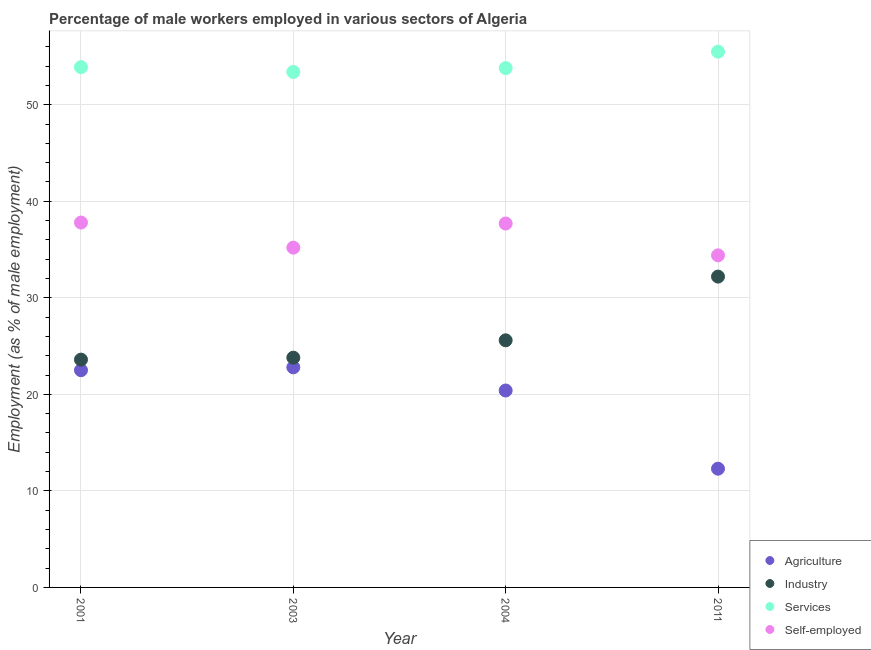How many different coloured dotlines are there?
Your answer should be very brief. 4. What is the percentage of male workers in industry in 2003?
Ensure brevity in your answer.  23.8. Across all years, what is the maximum percentage of male workers in services?
Make the answer very short. 55.5. Across all years, what is the minimum percentage of male workers in industry?
Your answer should be very brief. 23.6. In which year was the percentage of self employed male workers minimum?
Offer a very short reply. 2011. What is the total percentage of self employed male workers in the graph?
Give a very brief answer. 145.1. What is the difference between the percentage of male workers in services in 2004 and that in 2011?
Your answer should be very brief. -1.7. What is the difference between the percentage of male workers in services in 2011 and the percentage of male workers in agriculture in 2003?
Provide a succinct answer. 32.7. What is the average percentage of male workers in agriculture per year?
Keep it short and to the point. 19.5. In the year 2001, what is the difference between the percentage of male workers in services and percentage of male workers in agriculture?
Offer a terse response. 31.4. In how many years, is the percentage of male workers in services greater than 24 %?
Offer a terse response. 4. What is the ratio of the percentage of male workers in services in 2003 to that in 2004?
Your response must be concise. 0.99. Is the percentage of male workers in industry in 2003 less than that in 2004?
Your answer should be very brief. Yes. What is the difference between the highest and the second highest percentage of male workers in industry?
Provide a short and direct response. 6.6. What is the difference between the highest and the lowest percentage of male workers in services?
Your answer should be very brief. 2.1. Is it the case that in every year, the sum of the percentage of male workers in services and percentage of male workers in industry is greater than the sum of percentage of male workers in agriculture and percentage of self employed male workers?
Provide a succinct answer. Yes. Is it the case that in every year, the sum of the percentage of male workers in agriculture and percentage of male workers in industry is greater than the percentage of male workers in services?
Your answer should be very brief. No. Is the percentage of male workers in agriculture strictly greater than the percentage of male workers in services over the years?
Keep it short and to the point. No. Is the percentage of self employed male workers strictly less than the percentage of male workers in agriculture over the years?
Your response must be concise. No. Are the values on the major ticks of Y-axis written in scientific E-notation?
Keep it short and to the point. No. Does the graph contain any zero values?
Offer a very short reply. No. Does the graph contain grids?
Your answer should be compact. Yes. Where does the legend appear in the graph?
Provide a short and direct response. Bottom right. What is the title of the graph?
Offer a terse response. Percentage of male workers employed in various sectors of Algeria. What is the label or title of the Y-axis?
Your answer should be compact. Employment (as % of male employment). What is the Employment (as % of male employment) of Industry in 2001?
Your answer should be very brief. 23.6. What is the Employment (as % of male employment) in Services in 2001?
Provide a short and direct response. 53.9. What is the Employment (as % of male employment) of Self-employed in 2001?
Your answer should be compact. 37.8. What is the Employment (as % of male employment) of Agriculture in 2003?
Your response must be concise. 22.8. What is the Employment (as % of male employment) of Industry in 2003?
Make the answer very short. 23.8. What is the Employment (as % of male employment) of Services in 2003?
Your answer should be very brief. 53.4. What is the Employment (as % of male employment) of Self-employed in 2003?
Your answer should be very brief. 35.2. What is the Employment (as % of male employment) of Agriculture in 2004?
Provide a short and direct response. 20.4. What is the Employment (as % of male employment) of Industry in 2004?
Your response must be concise. 25.6. What is the Employment (as % of male employment) of Services in 2004?
Your answer should be compact. 53.8. What is the Employment (as % of male employment) in Self-employed in 2004?
Your answer should be compact. 37.7. What is the Employment (as % of male employment) in Agriculture in 2011?
Make the answer very short. 12.3. What is the Employment (as % of male employment) of Industry in 2011?
Keep it short and to the point. 32.2. What is the Employment (as % of male employment) in Services in 2011?
Provide a short and direct response. 55.5. What is the Employment (as % of male employment) in Self-employed in 2011?
Provide a succinct answer. 34.4. Across all years, what is the maximum Employment (as % of male employment) in Agriculture?
Your response must be concise. 22.8. Across all years, what is the maximum Employment (as % of male employment) of Industry?
Make the answer very short. 32.2. Across all years, what is the maximum Employment (as % of male employment) in Services?
Your answer should be compact. 55.5. Across all years, what is the maximum Employment (as % of male employment) in Self-employed?
Keep it short and to the point. 37.8. Across all years, what is the minimum Employment (as % of male employment) of Agriculture?
Give a very brief answer. 12.3. Across all years, what is the minimum Employment (as % of male employment) of Industry?
Make the answer very short. 23.6. Across all years, what is the minimum Employment (as % of male employment) in Services?
Provide a short and direct response. 53.4. Across all years, what is the minimum Employment (as % of male employment) of Self-employed?
Your answer should be very brief. 34.4. What is the total Employment (as % of male employment) of Agriculture in the graph?
Your answer should be compact. 78. What is the total Employment (as % of male employment) of Industry in the graph?
Offer a very short reply. 105.2. What is the total Employment (as % of male employment) in Services in the graph?
Give a very brief answer. 216.6. What is the total Employment (as % of male employment) of Self-employed in the graph?
Provide a short and direct response. 145.1. What is the difference between the Employment (as % of male employment) in Services in 2001 and that in 2003?
Give a very brief answer. 0.5. What is the difference between the Employment (as % of male employment) in Self-employed in 2001 and that in 2003?
Your answer should be compact. 2.6. What is the difference between the Employment (as % of male employment) in Agriculture in 2001 and that in 2004?
Give a very brief answer. 2.1. What is the difference between the Employment (as % of male employment) in Industry in 2001 and that in 2004?
Ensure brevity in your answer.  -2. What is the difference between the Employment (as % of male employment) of Services in 2001 and that in 2004?
Offer a very short reply. 0.1. What is the difference between the Employment (as % of male employment) of Self-employed in 2001 and that in 2004?
Provide a short and direct response. 0.1. What is the difference between the Employment (as % of male employment) in Industry in 2001 and that in 2011?
Keep it short and to the point. -8.6. What is the difference between the Employment (as % of male employment) in Services in 2001 and that in 2011?
Keep it short and to the point. -1.6. What is the difference between the Employment (as % of male employment) in Agriculture in 2003 and that in 2004?
Make the answer very short. 2.4. What is the difference between the Employment (as % of male employment) of Industry in 2003 and that in 2004?
Ensure brevity in your answer.  -1.8. What is the difference between the Employment (as % of male employment) of Services in 2003 and that in 2011?
Your answer should be compact. -2.1. What is the difference between the Employment (as % of male employment) of Self-employed in 2003 and that in 2011?
Make the answer very short. 0.8. What is the difference between the Employment (as % of male employment) of Industry in 2004 and that in 2011?
Your answer should be compact. -6.6. What is the difference between the Employment (as % of male employment) of Services in 2004 and that in 2011?
Ensure brevity in your answer.  -1.7. What is the difference between the Employment (as % of male employment) in Self-employed in 2004 and that in 2011?
Your response must be concise. 3.3. What is the difference between the Employment (as % of male employment) in Agriculture in 2001 and the Employment (as % of male employment) in Services in 2003?
Ensure brevity in your answer.  -30.9. What is the difference between the Employment (as % of male employment) of Industry in 2001 and the Employment (as % of male employment) of Services in 2003?
Your response must be concise. -29.8. What is the difference between the Employment (as % of male employment) of Industry in 2001 and the Employment (as % of male employment) of Self-employed in 2003?
Keep it short and to the point. -11.6. What is the difference between the Employment (as % of male employment) of Services in 2001 and the Employment (as % of male employment) of Self-employed in 2003?
Keep it short and to the point. 18.7. What is the difference between the Employment (as % of male employment) in Agriculture in 2001 and the Employment (as % of male employment) in Services in 2004?
Provide a succinct answer. -31.3. What is the difference between the Employment (as % of male employment) in Agriculture in 2001 and the Employment (as % of male employment) in Self-employed in 2004?
Your answer should be very brief. -15.2. What is the difference between the Employment (as % of male employment) in Industry in 2001 and the Employment (as % of male employment) in Services in 2004?
Your response must be concise. -30.2. What is the difference between the Employment (as % of male employment) in Industry in 2001 and the Employment (as % of male employment) in Self-employed in 2004?
Provide a short and direct response. -14.1. What is the difference between the Employment (as % of male employment) of Services in 2001 and the Employment (as % of male employment) of Self-employed in 2004?
Provide a short and direct response. 16.2. What is the difference between the Employment (as % of male employment) of Agriculture in 2001 and the Employment (as % of male employment) of Services in 2011?
Offer a terse response. -33. What is the difference between the Employment (as % of male employment) in Agriculture in 2001 and the Employment (as % of male employment) in Self-employed in 2011?
Keep it short and to the point. -11.9. What is the difference between the Employment (as % of male employment) in Industry in 2001 and the Employment (as % of male employment) in Services in 2011?
Make the answer very short. -31.9. What is the difference between the Employment (as % of male employment) of Agriculture in 2003 and the Employment (as % of male employment) of Industry in 2004?
Make the answer very short. -2.8. What is the difference between the Employment (as % of male employment) in Agriculture in 2003 and the Employment (as % of male employment) in Services in 2004?
Offer a terse response. -31. What is the difference between the Employment (as % of male employment) of Agriculture in 2003 and the Employment (as % of male employment) of Self-employed in 2004?
Your answer should be very brief. -14.9. What is the difference between the Employment (as % of male employment) of Industry in 2003 and the Employment (as % of male employment) of Self-employed in 2004?
Offer a very short reply. -13.9. What is the difference between the Employment (as % of male employment) of Agriculture in 2003 and the Employment (as % of male employment) of Services in 2011?
Your response must be concise. -32.7. What is the difference between the Employment (as % of male employment) in Industry in 2003 and the Employment (as % of male employment) in Services in 2011?
Offer a terse response. -31.7. What is the difference between the Employment (as % of male employment) in Industry in 2003 and the Employment (as % of male employment) in Self-employed in 2011?
Ensure brevity in your answer.  -10.6. What is the difference between the Employment (as % of male employment) in Services in 2003 and the Employment (as % of male employment) in Self-employed in 2011?
Provide a short and direct response. 19. What is the difference between the Employment (as % of male employment) in Agriculture in 2004 and the Employment (as % of male employment) in Services in 2011?
Make the answer very short. -35.1. What is the difference between the Employment (as % of male employment) of Agriculture in 2004 and the Employment (as % of male employment) of Self-employed in 2011?
Your answer should be compact. -14. What is the difference between the Employment (as % of male employment) of Industry in 2004 and the Employment (as % of male employment) of Services in 2011?
Keep it short and to the point. -29.9. What is the average Employment (as % of male employment) of Agriculture per year?
Provide a succinct answer. 19.5. What is the average Employment (as % of male employment) of Industry per year?
Offer a terse response. 26.3. What is the average Employment (as % of male employment) in Services per year?
Provide a succinct answer. 54.15. What is the average Employment (as % of male employment) in Self-employed per year?
Your response must be concise. 36.27. In the year 2001, what is the difference between the Employment (as % of male employment) of Agriculture and Employment (as % of male employment) of Industry?
Ensure brevity in your answer.  -1.1. In the year 2001, what is the difference between the Employment (as % of male employment) in Agriculture and Employment (as % of male employment) in Services?
Your response must be concise. -31.4. In the year 2001, what is the difference between the Employment (as % of male employment) of Agriculture and Employment (as % of male employment) of Self-employed?
Provide a succinct answer. -15.3. In the year 2001, what is the difference between the Employment (as % of male employment) in Industry and Employment (as % of male employment) in Services?
Keep it short and to the point. -30.3. In the year 2001, what is the difference between the Employment (as % of male employment) of Services and Employment (as % of male employment) of Self-employed?
Offer a very short reply. 16.1. In the year 2003, what is the difference between the Employment (as % of male employment) of Agriculture and Employment (as % of male employment) of Services?
Provide a short and direct response. -30.6. In the year 2003, what is the difference between the Employment (as % of male employment) in Agriculture and Employment (as % of male employment) in Self-employed?
Your answer should be compact. -12.4. In the year 2003, what is the difference between the Employment (as % of male employment) in Industry and Employment (as % of male employment) in Services?
Offer a very short reply. -29.6. In the year 2003, what is the difference between the Employment (as % of male employment) of Industry and Employment (as % of male employment) of Self-employed?
Your answer should be very brief. -11.4. In the year 2004, what is the difference between the Employment (as % of male employment) of Agriculture and Employment (as % of male employment) of Industry?
Provide a succinct answer. -5.2. In the year 2004, what is the difference between the Employment (as % of male employment) of Agriculture and Employment (as % of male employment) of Services?
Give a very brief answer. -33.4. In the year 2004, what is the difference between the Employment (as % of male employment) in Agriculture and Employment (as % of male employment) in Self-employed?
Your answer should be very brief. -17.3. In the year 2004, what is the difference between the Employment (as % of male employment) of Industry and Employment (as % of male employment) of Services?
Give a very brief answer. -28.2. In the year 2004, what is the difference between the Employment (as % of male employment) of Industry and Employment (as % of male employment) of Self-employed?
Make the answer very short. -12.1. In the year 2011, what is the difference between the Employment (as % of male employment) in Agriculture and Employment (as % of male employment) in Industry?
Provide a short and direct response. -19.9. In the year 2011, what is the difference between the Employment (as % of male employment) in Agriculture and Employment (as % of male employment) in Services?
Keep it short and to the point. -43.2. In the year 2011, what is the difference between the Employment (as % of male employment) of Agriculture and Employment (as % of male employment) of Self-employed?
Keep it short and to the point. -22.1. In the year 2011, what is the difference between the Employment (as % of male employment) in Industry and Employment (as % of male employment) in Services?
Offer a terse response. -23.3. In the year 2011, what is the difference between the Employment (as % of male employment) of Industry and Employment (as % of male employment) of Self-employed?
Your response must be concise. -2.2. In the year 2011, what is the difference between the Employment (as % of male employment) of Services and Employment (as % of male employment) of Self-employed?
Make the answer very short. 21.1. What is the ratio of the Employment (as % of male employment) in Agriculture in 2001 to that in 2003?
Provide a short and direct response. 0.99. What is the ratio of the Employment (as % of male employment) of Services in 2001 to that in 2003?
Your response must be concise. 1.01. What is the ratio of the Employment (as % of male employment) of Self-employed in 2001 to that in 2003?
Your answer should be compact. 1.07. What is the ratio of the Employment (as % of male employment) in Agriculture in 2001 to that in 2004?
Provide a succinct answer. 1.1. What is the ratio of the Employment (as % of male employment) of Industry in 2001 to that in 2004?
Provide a succinct answer. 0.92. What is the ratio of the Employment (as % of male employment) of Services in 2001 to that in 2004?
Provide a short and direct response. 1. What is the ratio of the Employment (as % of male employment) in Agriculture in 2001 to that in 2011?
Give a very brief answer. 1.83. What is the ratio of the Employment (as % of male employment) in Industry in 2001 to that in 2011?
Keep it short and to the point. 0.73. What is the ratio of the Employment (as % of male employment) of Services in 2001 to that in 2011?
Provide a short and direct response. 0.97. What is the ratio of the Employment (as % of male employment) of Self-employed in 2001 to that in 2011?
Provide a short and direct response. 1.1. What is the ratio of the Employment (as % of male employment) of Agriculture in 2003 to that in 2004?
Keep it short and to the point. 1.12. What is the ratio of the Employment (as % of male employment) of Industry in 2003 to that in 2004?
Keep it short and to the point. 0.93. What is the ratio of the Employment (as % of male employment) in Services in 2003 to that in 2004?
Your answer should be compact. 0.99. What is the ratio of the Employment (as % of male employment) of Self-employed in 2003 to that in 2004?
Ensure brevity in your answer.  0.93. What is the ratio of the Employment (as % of male employment) in Agriculture in 2003 to that in 2011?
Offer a very short reply. 1.85. What is the ratio of the Employment (as % of male employment) in Industry in 2003 to that in 2011?
Keep it short and to the point. 0.74. What is the ratio of the Employment (as % of male employment) of Services in 2003 to that in 2011?
Keep it short and to the point. 0.96. What is the ratio of the Employment (as % of male employment) in Self-employed in 2003 to that in 2011?
Provide a short and direct response. 1.02. What is the ratio of the Employment (as % of male employment) in Agriculture in 2004 to that in 2011?
Offer a terse response. 1.66. What is the ratio of the Employment (as % of male employment) of Industry in 2004 to that in 2011?
Your answer should be very brief. 0.8. What is the ratio of the Employment (as % of male employment) of Services in 2004 to that in 2011?
Offer a terse response. 0.97. What is the ratio of the Employment (as % of male employment) of Self-employed in 2004 to that in 2011?
Provide a short and direct response. 1.1. What is the difference between the highest and the lowest Employment (as % of male employment) in Industry?
Your answer should be compact. 8.6. What is the difference between the highest and the lowest Employment (as % of male employment) of Self-employed?
Offer a very short reply. 3.4. 